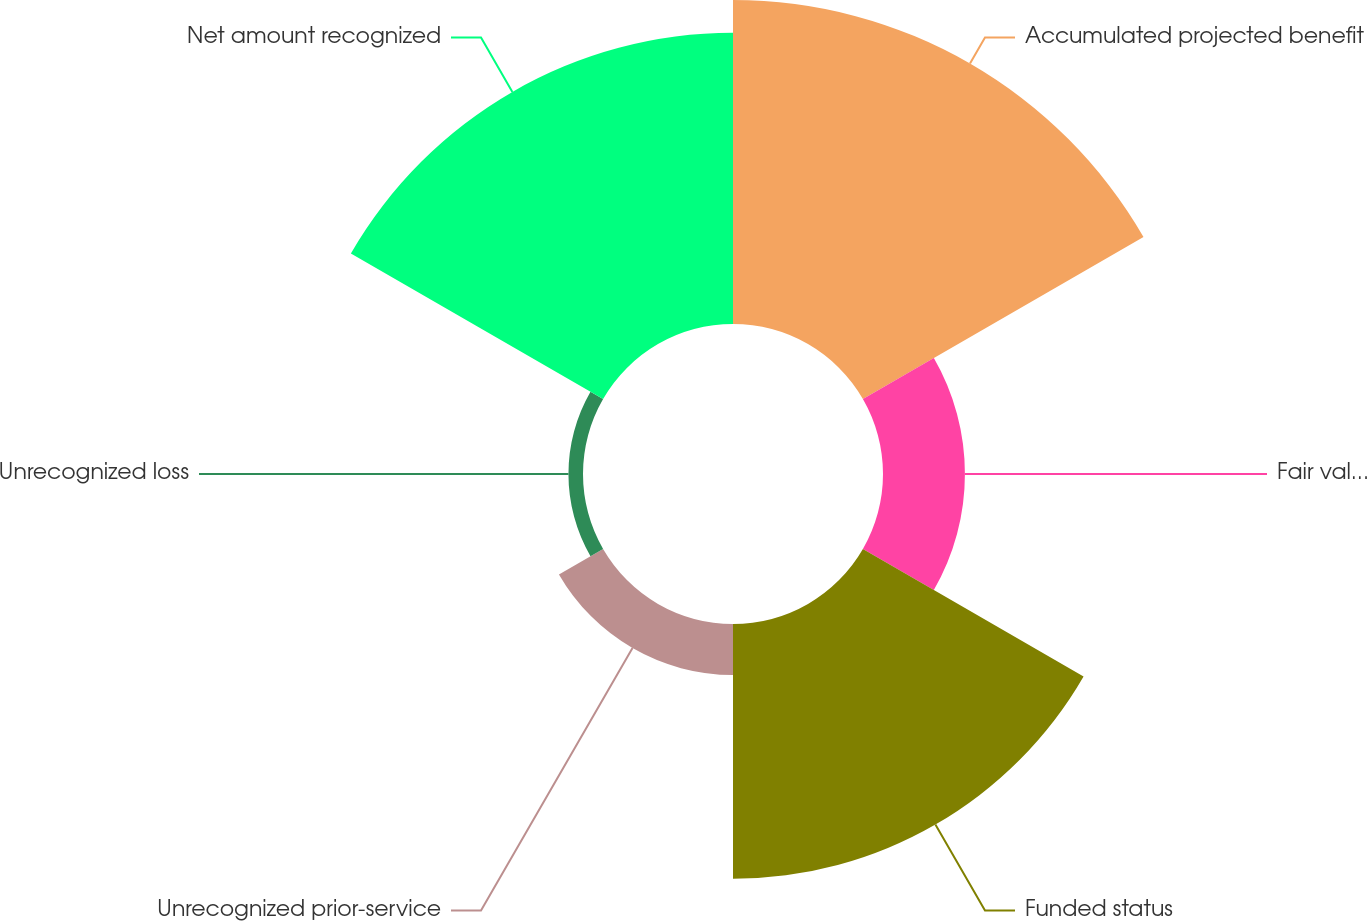Convert chart to OTSL. <chart><loc_0><loc_0><loc_500><loc_500><pie_chart><fcel>Accumulated projected benefit<fcel>Fair value of plan assets<fcel>Funded status<fcel>Unrecognized prior-service<fcel>Unrecognized loss<fcel>Net amount recognized<nl><fcel>31.84%<fcel>8.05%<fcel>25.04%<fcel>5.01%<fcel>1.43%<fcel>28.62%<nl></chart> 